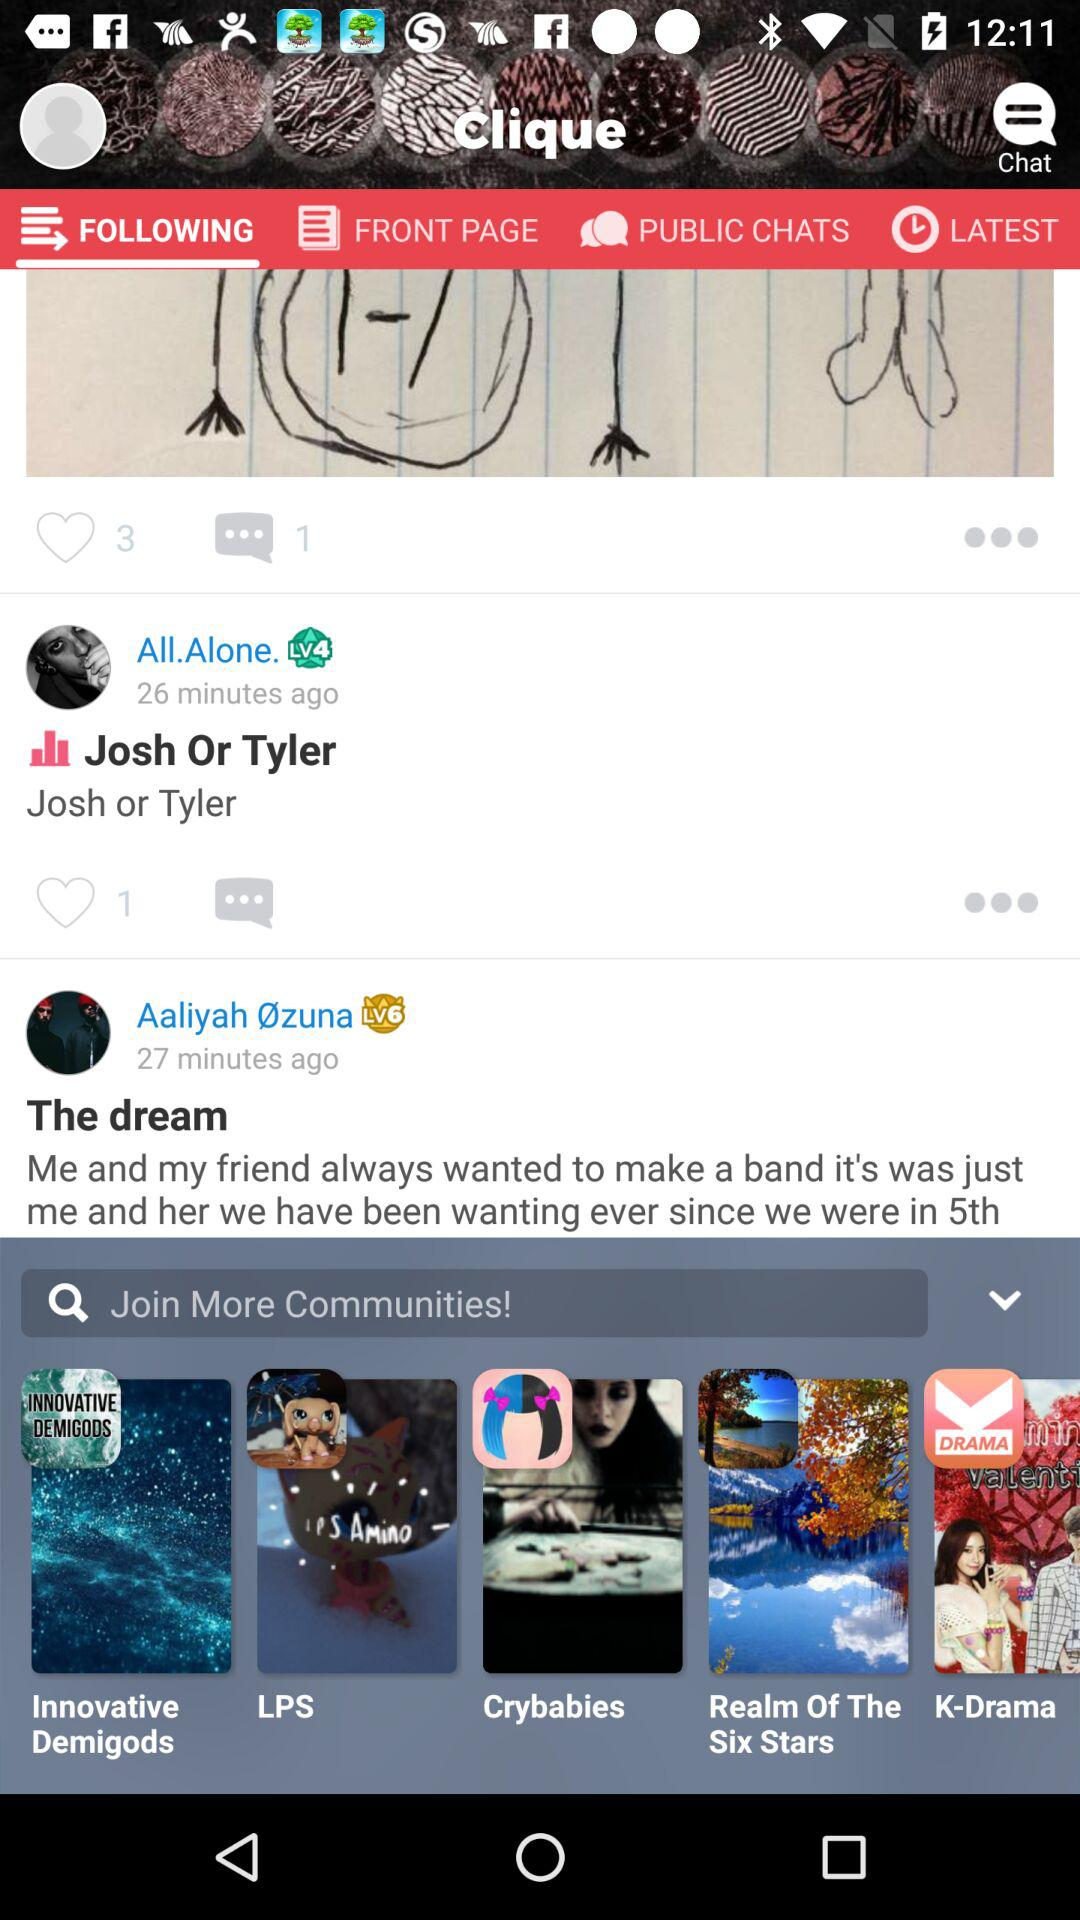How many minutes ago did "All.Alone." post? "All.Alone." posted 26 minutes ago. 